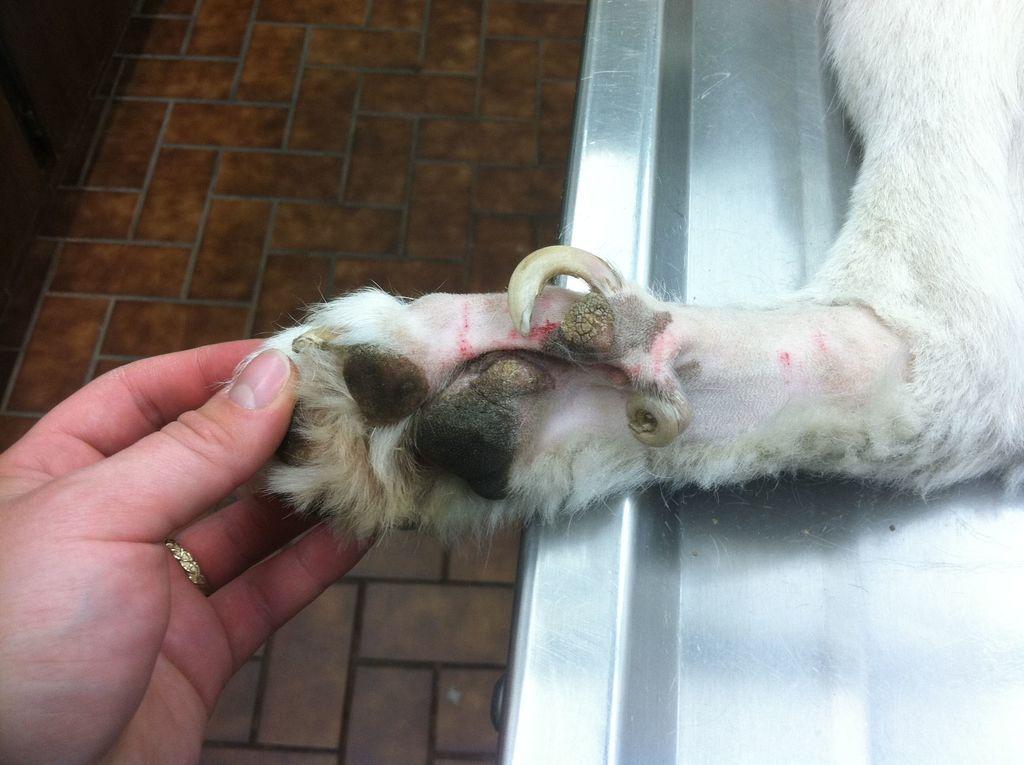Could you give a brief overview of what you see in this image? In this image we can see there is a person holding the leg of a animal. 